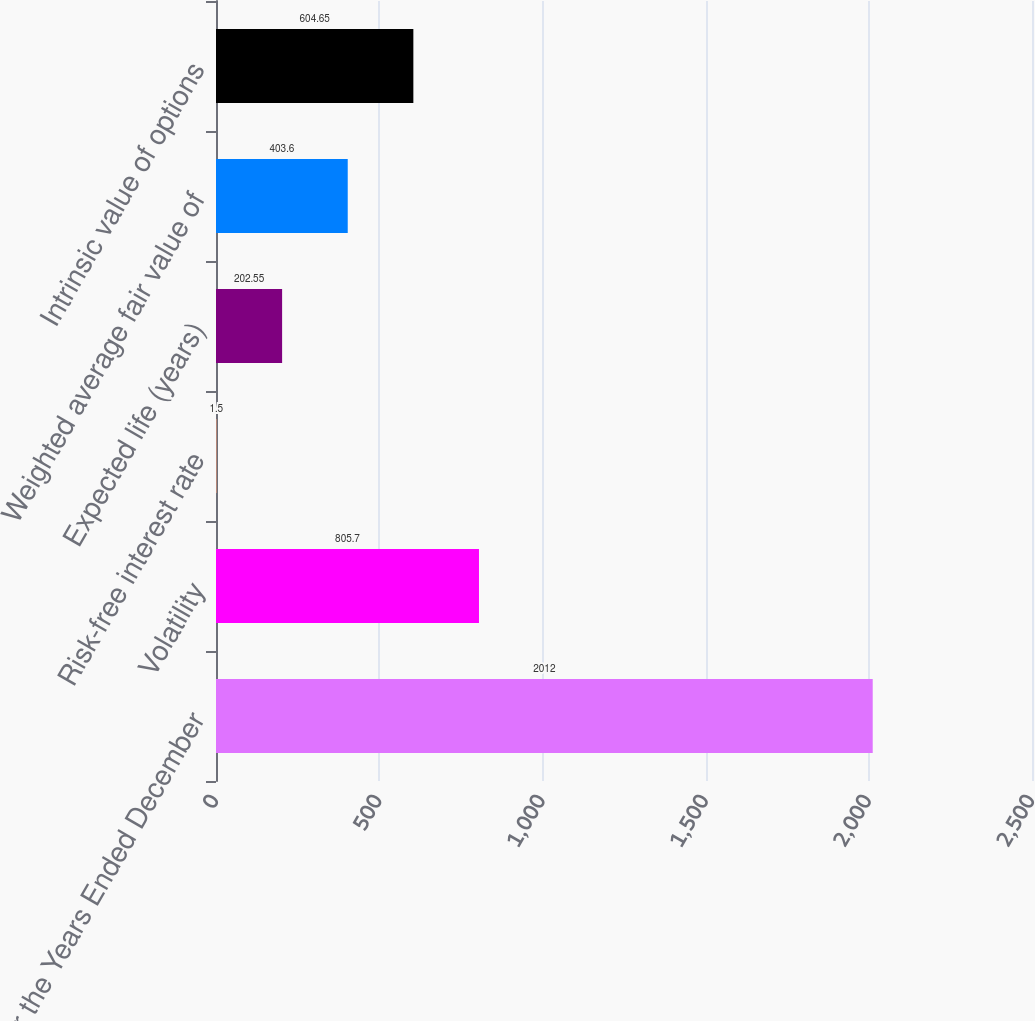Convert chart. <chart><loc_0><loc_0><loc_500><loc_500><bar_chart><fcel>For the Years Ended December<fcel>Volatility<fcel>Risk-free interest rate<fcel>Expected life (years)<fcel>Weighted average fair value of<fcel>Intrinsic value of options<nl><fcel>2012<fcel>805.7<fcel>1.5<fcel>202.55<fcel>403.6<fcel>604.65<nl></chart> 